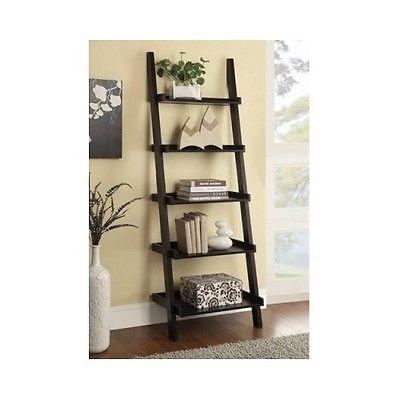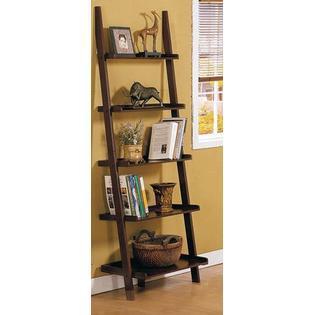The first image is the image on the left, the second image is the image on the right. Considering the images on both sides, is "Both shelf units can stand on their own." valid? Answer yes or no. No. The first image is the image on the left, the second image is the image on the right. Evaluate the accuracy of this statement regarding the images: "The left image shows a dark bookcase with short legs, a top part that is open, and a bottom part at least partly closed.". Is it true? Answer yes or no. No. 